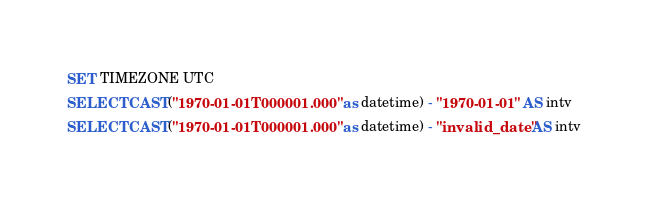<code> <loc_0><loc_0><loc_500><loc_500><_SQL_>SET TIMEZONE UTC
SELECT CAST("1970-01-01T000001.000" as datetime) - "1970-01-01" AS intv
SELECT CAST("1970-01-01T000001.000" as datetime) - "invalid_date" AS intv
</code> 